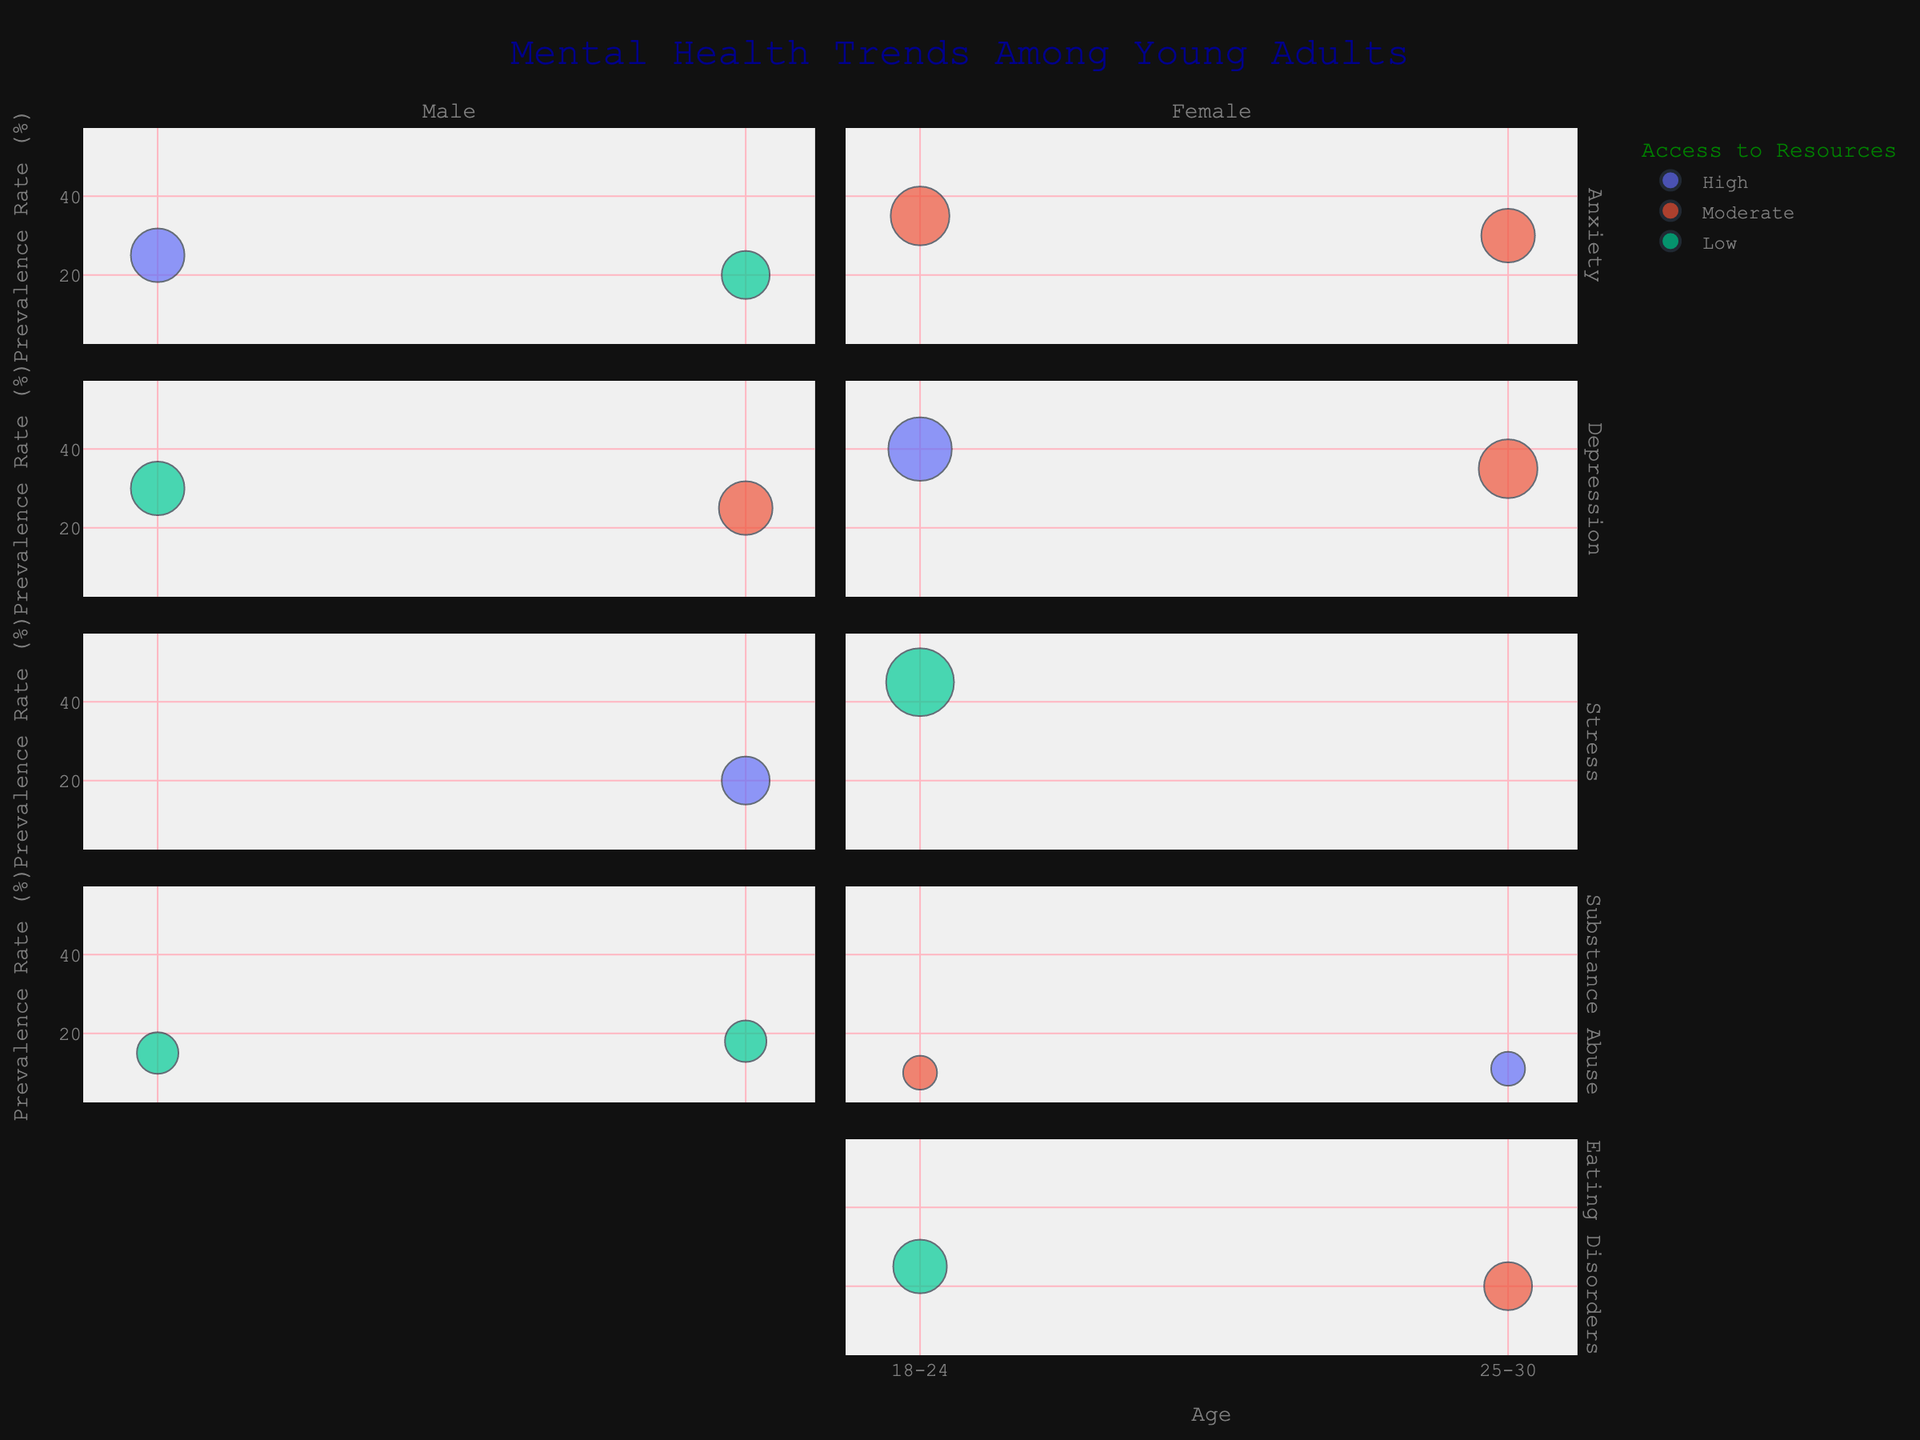What is the title of the bubble chart? The title of the chart is prominently displayed at the top. It reads "Mental Health Trends Among Young Adults."
Answer: Mental Health Trends Among Young Adults Which gender has a higher prevalence rate for depression in the 18-24 age group? In the 18-24 age group, the bubble representing females has a higher prevalence rate for depression compared to males. The rate for females is 40% while it is 30% for males.
Answer: Female What are the access to resources levels for males and females aged 25-30 experiencing anxiety? For males aged 25-30 experiencing anxiety, the access to resources is low. For females in this same category, it is moderate.
Answer: Male: Low, Female: Moderate Which symptom in the 18-24 age group has the largest bubble size? The largest bubble size in the 18-24 age group pertains to females experiencing stress, with a bubble size of 8.
Answer: Stress Compare the prevalence rates of anxiety for males and females in the 18-24 age group? Males in the 18-24 age group have a prevalence rate of 25% for anxiety, while females in the same group have a higher rate of 35%.
Answer: Females have a higher prevalence rate than males How does the access to resources for eating disorders differ between the two age groups for females? Females with eating disorders in the 18-24 age group have low access to resources, whereas those in the 25-30 age group have moderate access.
Answer: 18-24: Low, 25-30: Moderate Which age group and gender combination has the highest prevalence rate for stress? Within the age and gender combinations, females aged 18-24 have the highest prevalence rate for stress at 45%.
Answer: Females aged 18-24 What is the combined prevalence rate of substance abuse for males across both age groups? For males, the prevalence rates of substance abuse are 15% in the 18-24 age group and 18% in the 25-30 age group. The combined prevalence rate is 15 + 18 = 33%.
Answer: 33% Which age group has a higher prevalence rate of depression for males, and by how much? For males, the prevalence rate of depression in the 18-24 age group is 30%, and in the 25-30 age group, it is 25%. Therefore, the 18-24 age group has a higher rate by 5%.
Answer: 18-24 by 5% If the access to resources was perfect (high) for all symptoms, would the prevalence rates be expected to increase, decrease, or largely stay the same? If the access to resources was perfect for all symptoms, it would likely contribute to a decrease in prevalence rates because better access to resources typically leads to better management and treatment of mental health issues.
Answer: Decrease 